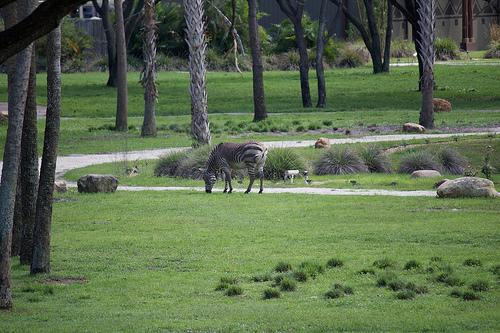What kind of road is depicted in the image and what is its color? A dirt road in a park is shown in the image, the road appears grayish and made of gravel. Name two objects you can find near the dirt road in the image. A big boulder and a large rock can be found near the dirt road in the image. What type of plants can be observed in the image and where are they located? A cluster of wild crab grass, tufts of grass in a field, and little patches of grass can be seen in various parts of the field. Make a poetic reference to the scene in the image. In the realms of a verdant field, zebras gracefully graze, amidst the whispers of wind through towering trees, where earth and sky embrace on a dirt path. Provide a vague description of where the zebra is located within the image. The zebra can be found standing in a field, somewhere near the grass and the road. In a fictional advertisement for a nature park, mention key features in the image to attract visitors. Explore our serene nature park with unique features such as zebras grazing on wild grass, tall palm trees, a tranquil dirt walking path, and beautiful rocky landscapes. What is the main difference between a giraffe and a zebra in the given image? In the image, the giraffe is a misidentification of the zebra, which is the actual animal present, displaying black and white stripes while grazing on the grass. Provide a brief description of the predominant animal in the image. An adult zebra is standing and grazing on the grass with its head angled down while displaying its black and white stripes. Identify the different types of trees in the image and provide a brief description for each. A skinny tree with thin dark trunk, tall palm trees with textured bark, and a spiky tree with pointy, dark green bush can be seen in the image. Multiple choice: What object is most closely associated with the zebra? b) gravel road 